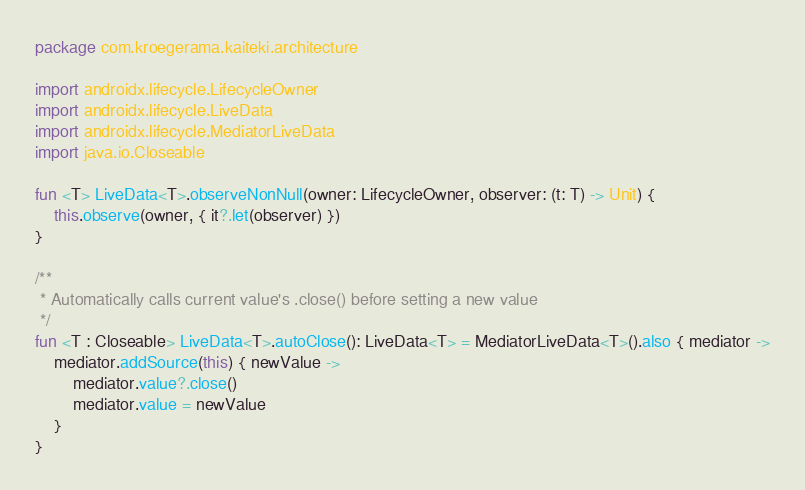<code> <loc_0><loc_0><loc_500><loc_500><_Kotlin_>package com.kroegerama.kaiteki.architecture

import androidx.lifecycle.LifecycleOwner
import androidx.lifecycle.LiveData
import androidx.lifecycle.MediatorLiveData
import java.io.Closeable

fun <T> LiveData<T>.observeNonNull(owner: LifecycleOwner, observer: (t: T) -> Unit) {
    this.observe(owner, { it?.let(observer) })
}

/**
 * Automatically calls current value's .close() before setting a new value
 */
fun <T : Closeable> LiveData<T>.autoClose(): LiveData<T> = MediatorLiveData<T>().also { mediator ->
    mediator.addSource(this) { newValue ->
        mediator.value?.close()
        mediator.value = newValue
    }
}</code> 